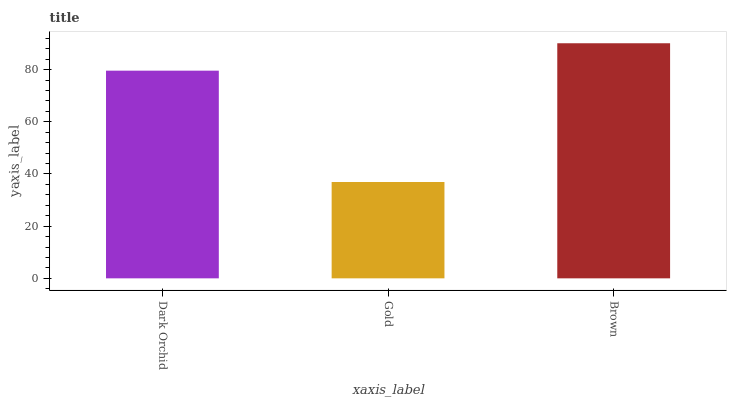Is Gold the minimum?
Answer yes or no. Yes. Is Brown the maximum?
Answer yes or no. Yes. Is Brown the minimum?
Answer yes or no. No. Is Gold the maximum?
Answer yes or no. No. Is Brown greater than Gold?
Answer yes or no. Yes. Is Gold less than Brown?
Answer yes or no. Yes. Is Gold greater than Brown?
Answer yes or no. No. Is Brown less than Gold?
Answer yes or no. No. Is Dark Orchid the high median?
Answer yes or no. Yes. Is Dark Orchid the low median?
Answer yes or no. Yes. Is Gold the high median?
Answer yes or no. No. Is Brown the low median?
Answer yes or no. No. 